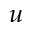<formula> <loc_0><loc_0><loc_500><loc_500>u</formula> 